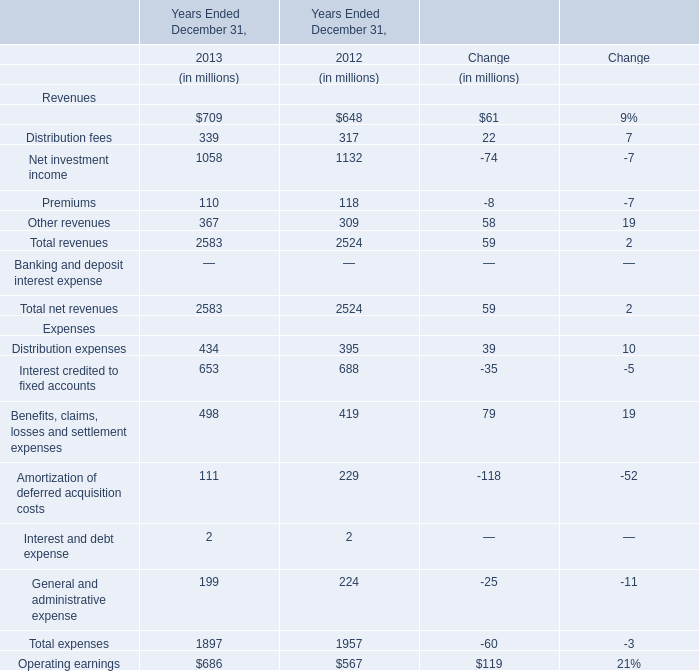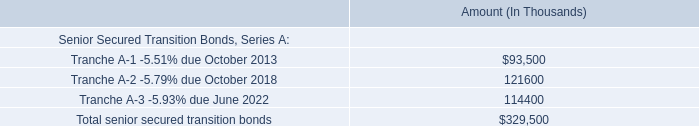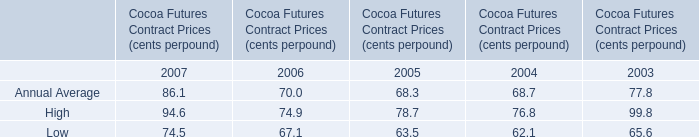what is the principal payment in 2020 as a percentage of the total senior secured transition bonds? 
Computations: ((32.8 * 1000) / 329500)
Answer: 0.09954. 